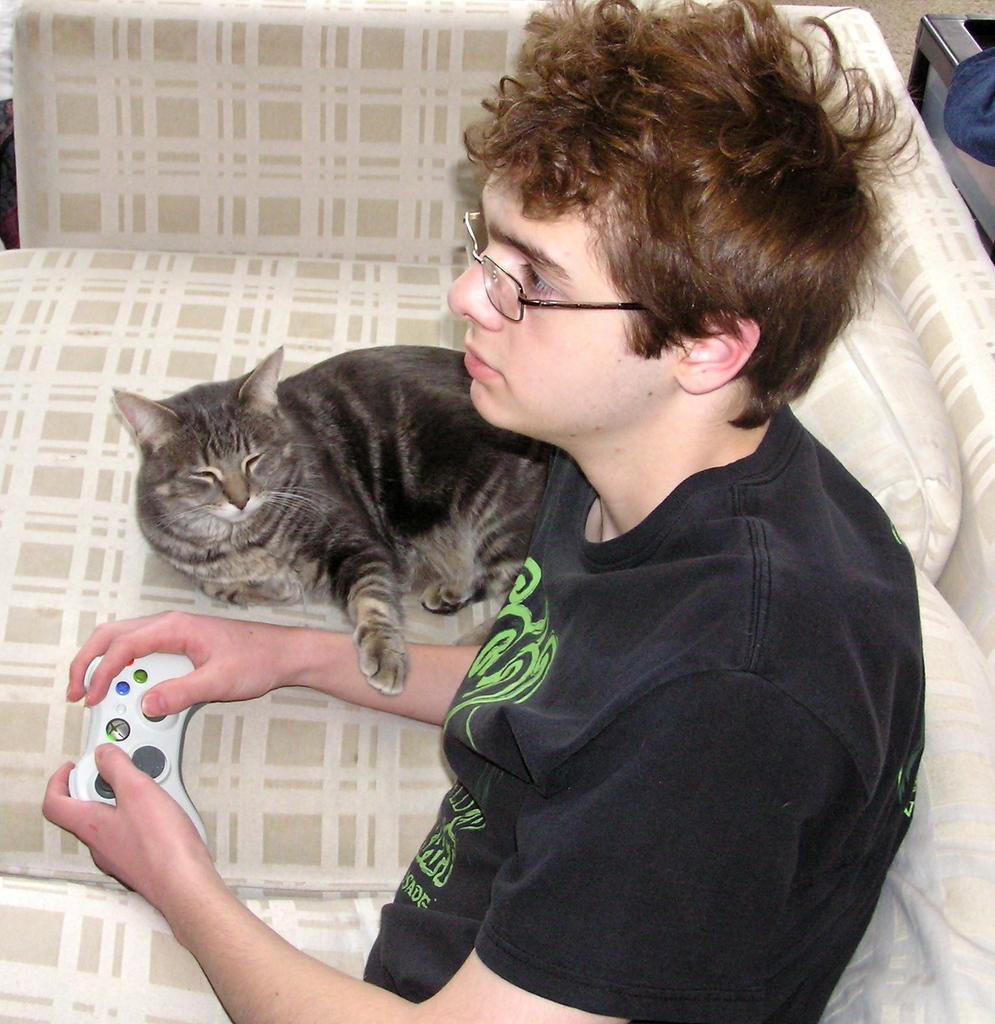What is the person in the image doing? The person is sitting on a couch. What is the person holding in his hand? The person is holding a toy in his hand. Is there any other living creature visible in the image? Yes, there is a cat lying on the couch beside the person. What type of blood is visible on the toy in the image? There is no blood visible in the image, and the toy is not mentioned as having any blood on it. 